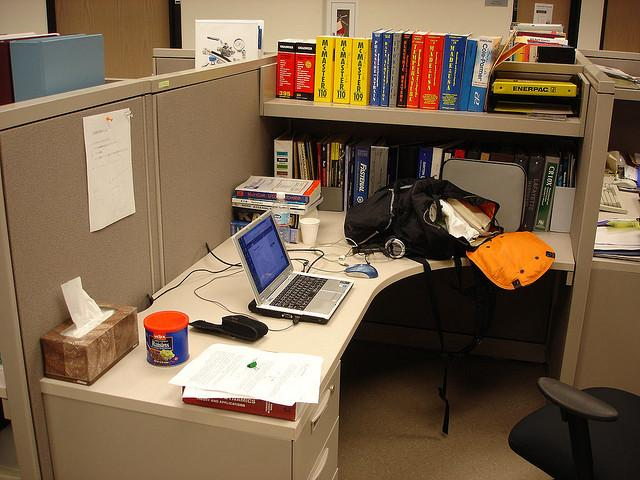What type of internet device is in use at this desk?

Choices:
A) desktop computer
B) tablet
C) smartphone
D) laptop computer desktop computer 